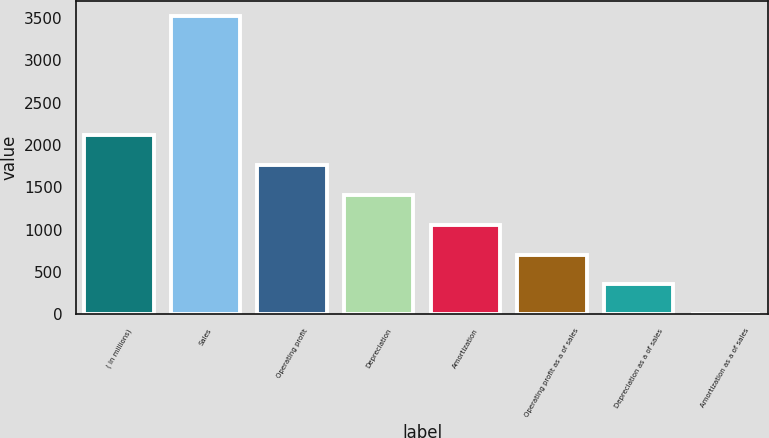Convert chart to OTSL. <chart><loc_0><loc_0><loc_500><loc_500><bar_chart><fcel>( in millions)<fcel>Sales<fcel>Operating profit<fcel>Depreciation<fcel>Amortization<fcel>Operating profit as a of sales<fcel>Depreciation as a of sales<fcel>Amortization as a of sales<nl><fcel>2115.96<fcel>3525.8<fcel>1763.5<fcel>1411.04<fcel>1058.58<fcel>706.12<fcel>353.66<fcel>1.2<nl></chart> 